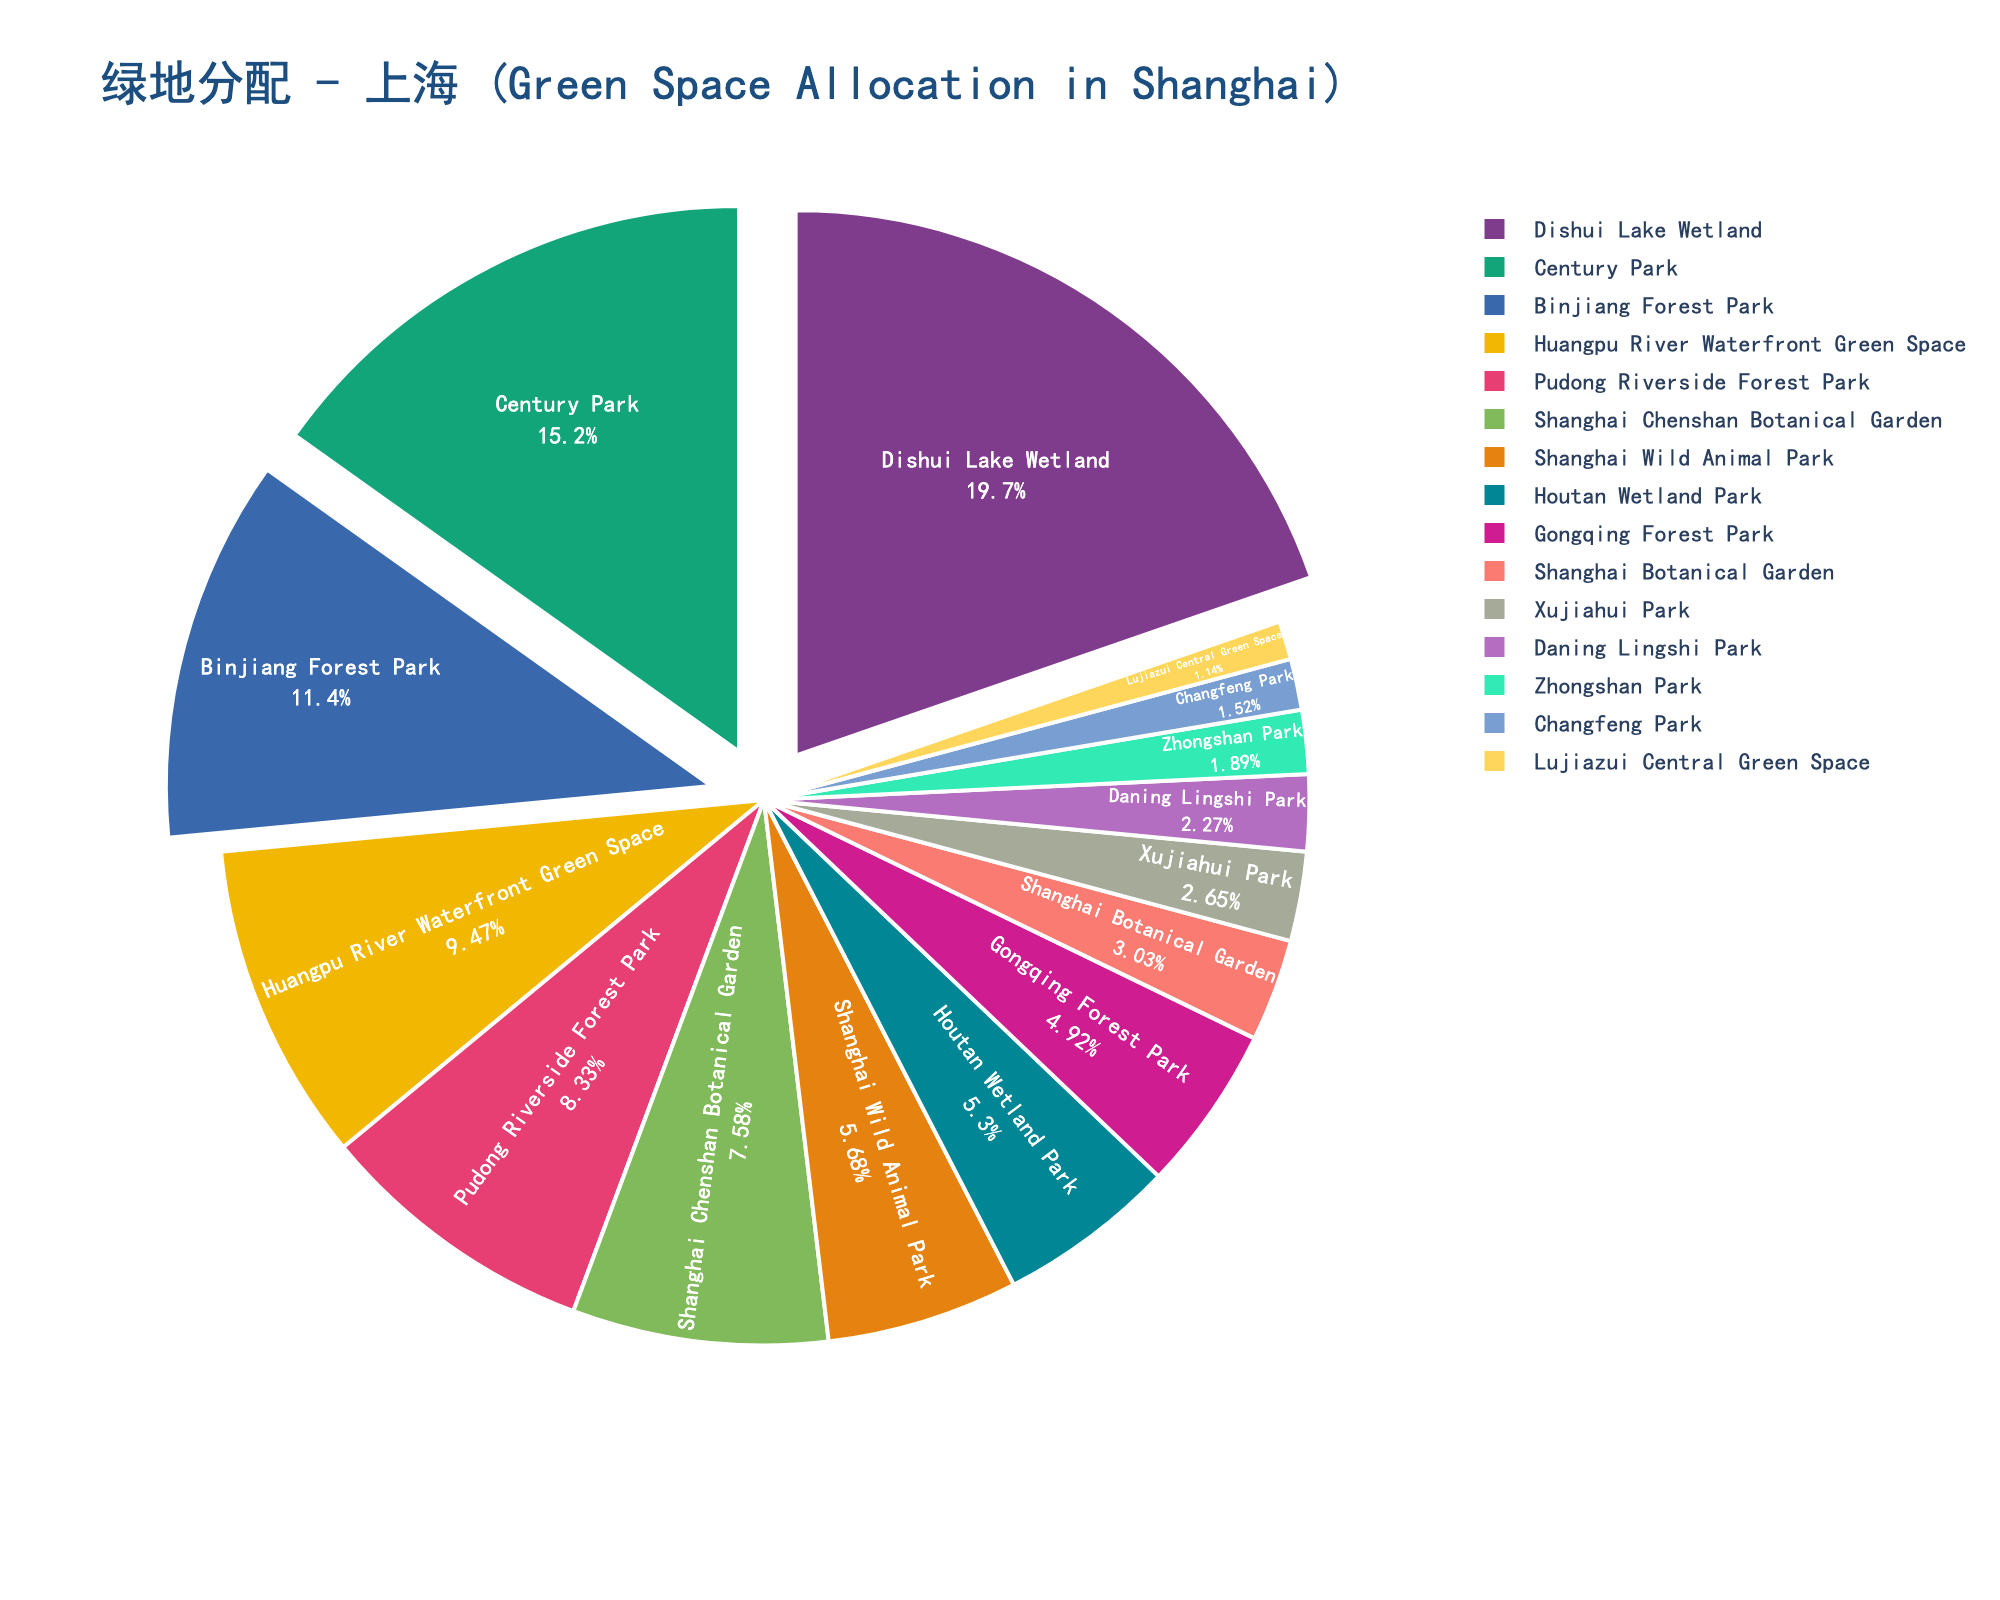What's the park with the largest area in Shanghai's green space allocation pie chart? To find the park with the largest area, look at the segment with the highest percentage on the pie chart. The corresponding label will provide the name.
Answer: Dishui Lake Wetland What is the combined area (sq km) of Century Park and Dishui Lake Wetland? Century Park is 4.0 sq km, and Dishui Lake Wetland is 5.2 sq km. Add these two values together: 4.0 + 5.2 = 9.2 sq km.
Answer: 9.2 sq km Which park has a larger area: Gongqing Forest Park or Shanghai Wild Animal Park? Compare the percentages or the area values directly from the chart. Gongqing Forest Park has 1.3 sq km, whereas Shanghai Wild Animal Park has 1.5 sq km.
Answer: Shanghai Wild Animal Park Which type of green space occupies the smallest segment on the pie chart? Look for the smallest segment in the pie chart. The label on this segment will identify the corresponding green space.
Answer: Lujiazui Central Green Space What is the total area of the parks listed on the pie chart? Sum up all the area values of the parks: 4.0 + 0.8 + 1.3 + 1.5 + 5.2 + 3.0 + 2.5 + 0.4 + 2.2 + 0.6 + 1.4 + 2.0 + 0.3 + 0.5 + 0.7 = 26.4 sq km.
Answer: 26.4 sq km Which parks have an area larger than 2.0 sq km? Identify the parks with area values greater than 2.0 sq km: Dishui Lake Wetland (5.2), Binjiang Forest Park (3.0), Huangpu River Waterfront Green Space (2.5), Pudong Riverside Forest Park (2.2), and Shanghai Chenshan Botanical Garden (2.0). Note: The 'greater than' rule excludes Shanghai Chenshan Botanical Garden so it should not be listed.
Answer: Dishui Lake Wetland, Binjiang Forest Park, Huangpu River Waterfront Green Space, Pudong Riverside Forest Park If we were to add all the green spaces with areas less than 1.0 sq km, what would be the total? Find and sum the areas of green spaces with less than 1.0 sq km: Shanghai Botanical Garden (0.8), Changfeng Park (0.4), Daning Lingshi Park (0.6), Lujiazui Central Green Space (0.3), Zhongshan Park (0.5), Xujiahui Park (0.7). Sum: 0.8 + 0.4 + 0.6 + 0.3 + 0.5 + 0.7 = 3.3 sq km.
Answer: 3.3 sq km What's the average area of green spaces in Shanghai's green space allocation? Calculate the total area and divide it by the number of green spaces (15): Total area = 26.4 sq km; Number of parks = 15; Average = 26.4 / 15 = 1.76 sq km.
Answer: 1.76 sq km 